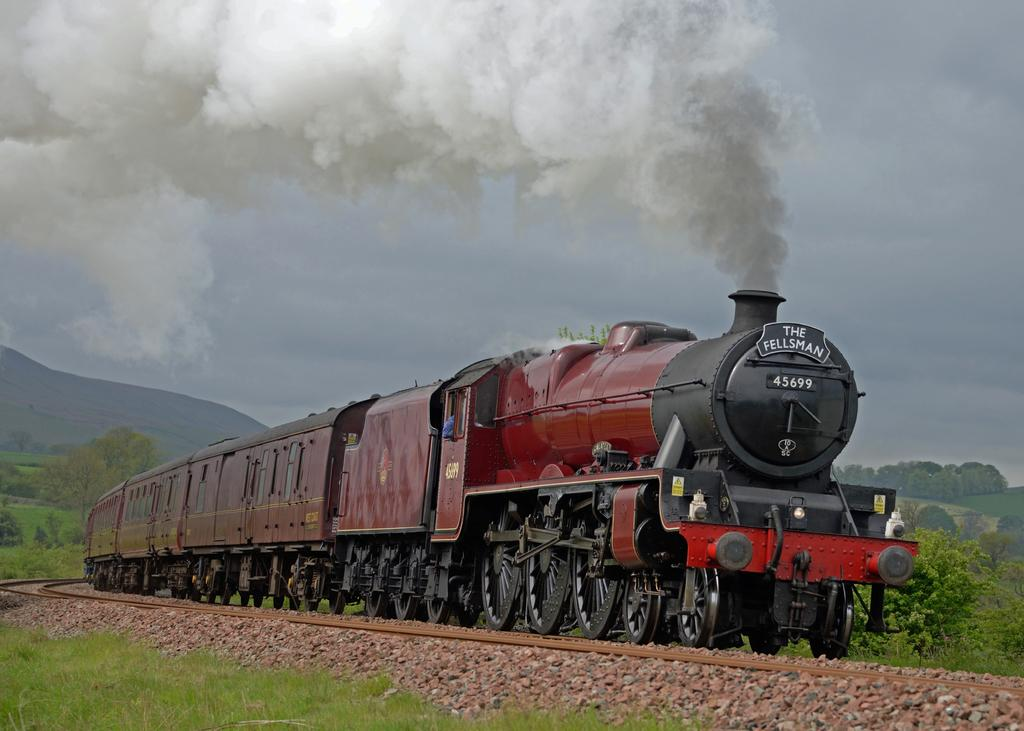What is on the track in the image? There is a train on the track in the image. What type of vegetation can be seen in the image? Grass and trees are visible in the image. What type of terrain is present in the image? Stones are present in the image. What is coming out of the train in the image? Smoke is visible in the image. What can be seen in the background of the image? There is a mountain and the sky visible in the background. Where is the store located in the image? There is no store present in the image. What type of dirt is visible on the train in the image? There is no dirt visible on the train in the image. 